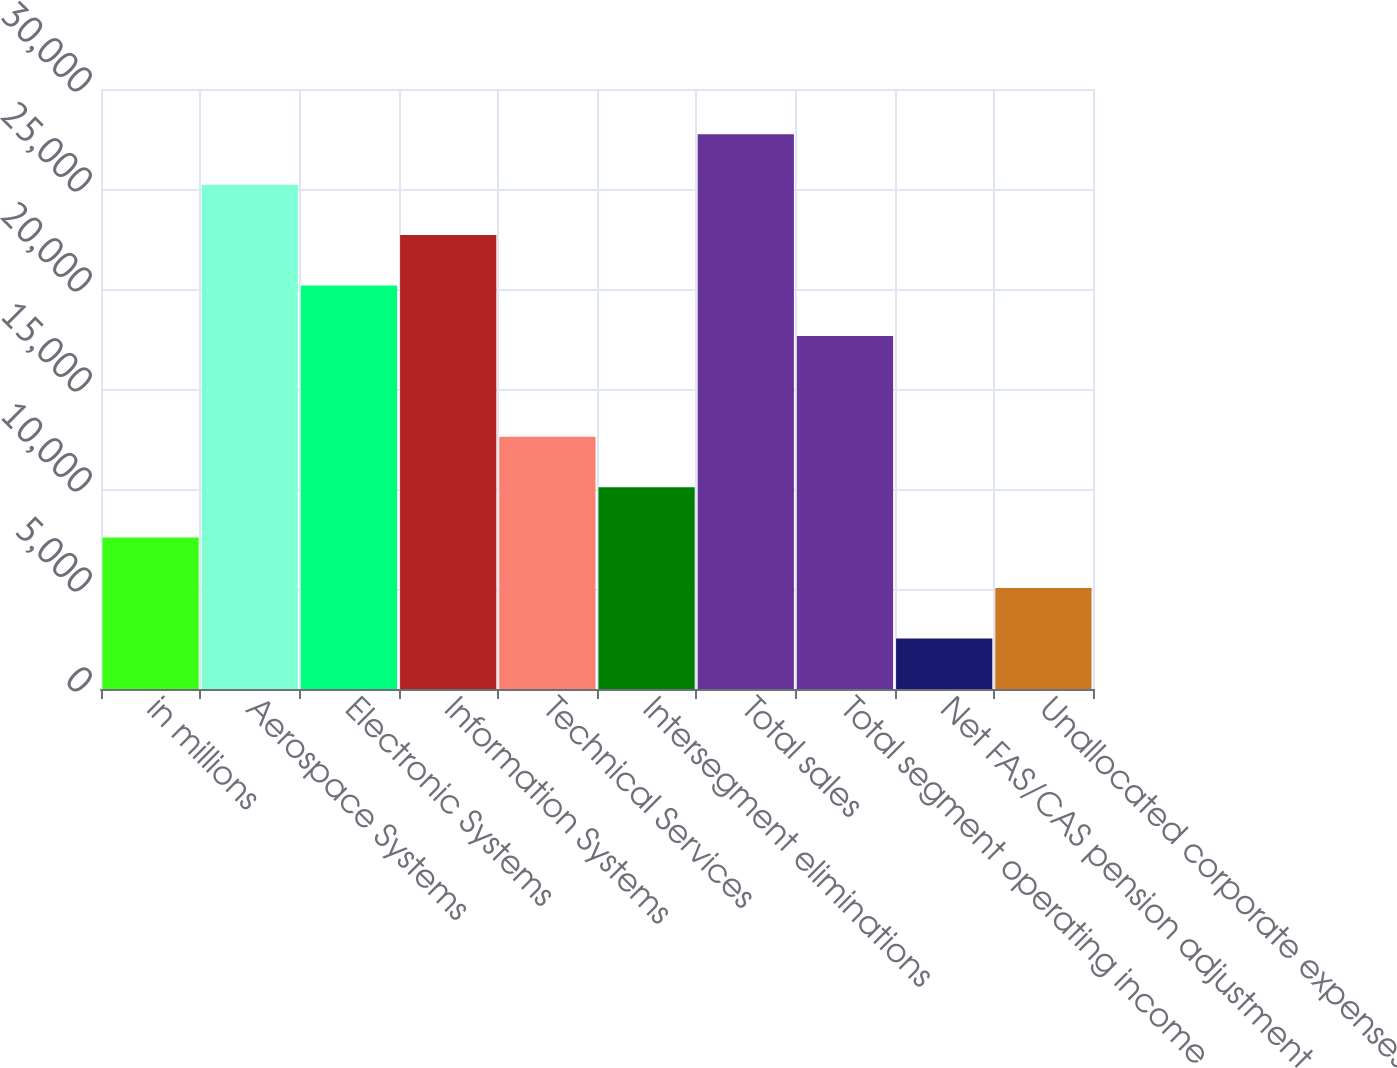Convert chart. <chart><loc_0><loc_0><loc_500><loc_500><bar_chart><fcel>in millions<fcel>Aerospace Systems<fcel>Electronic Systems<fcel>Information Systems<fcel>Technical Services<fcel>Intersegment eliminations<fcel>Total sales<fcel>Total segment operating income<fcel>Net FAS/CAS pension adjustment<fcel>Unallocated corporate expenses<nl><fcel>7572.4<fcel>25218<fcel>20176.4<fcel>22697.2<fcel>12614<fcel>10093.2<fcel>27738.8<fcel>17655.6<fcel>2530.8<fcel>5051.6<nl></chart> 